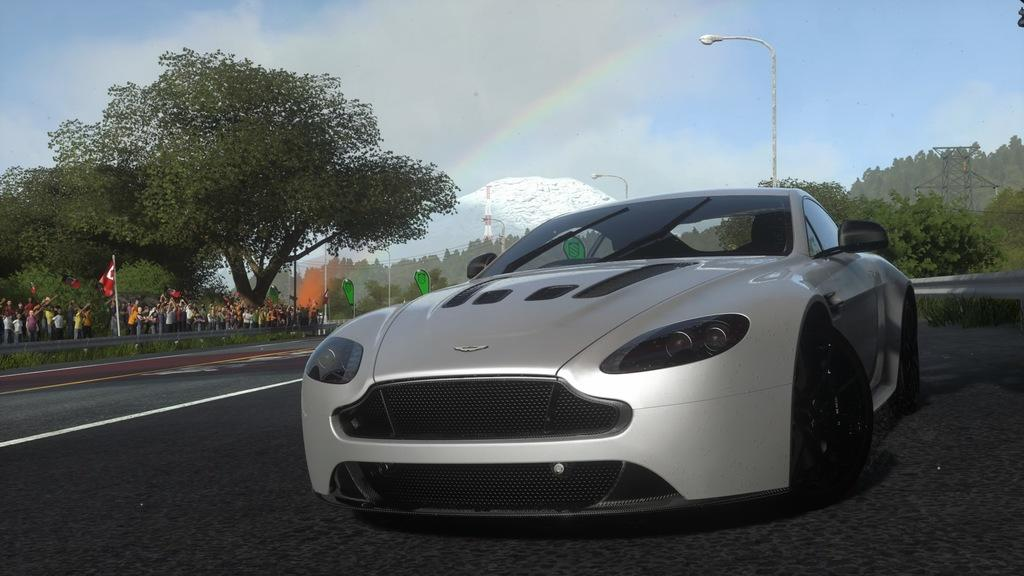What is the main subject of the image? There is a vehicle in the image. What is the setting of the image? The image features a road, ground with grass, trees, and a mountain. What structures are present in the image? There are poles, lights, towers, and fencing in the image. What natural phenomena can be seen in the image? There is a rainbow and the sky with clouds visible in the image. How much does the coast weigh in the image? There is no coast present in the image, so it is not possible to determine its weight. 